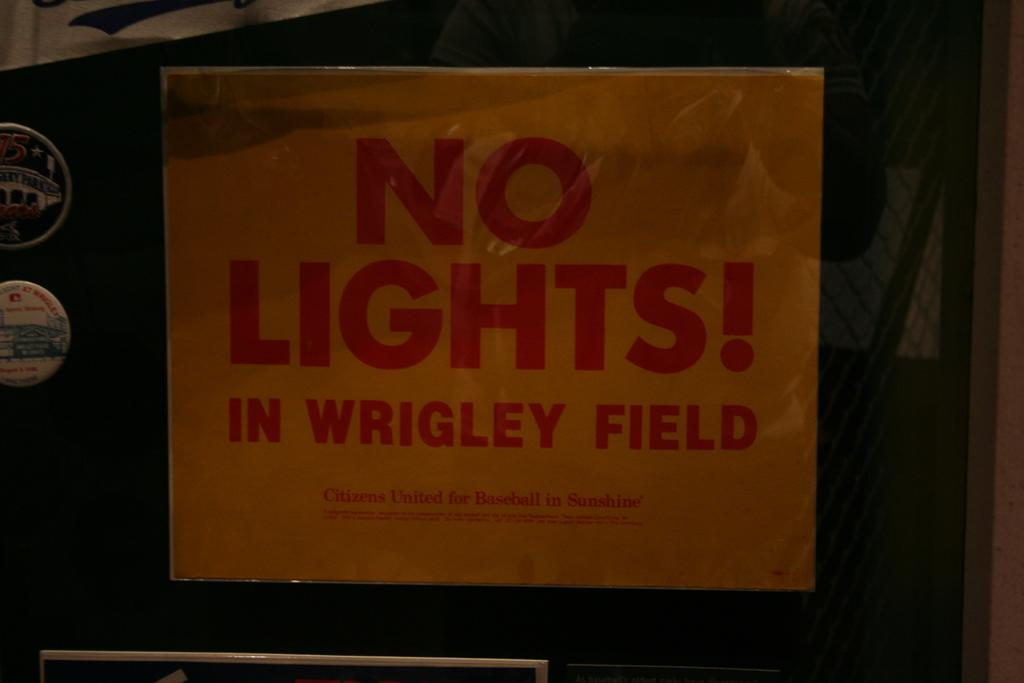<image>
Provide a brief description of the given image. A black bulletin board with a yellow sign that reads no lights in Wrigley Field. 